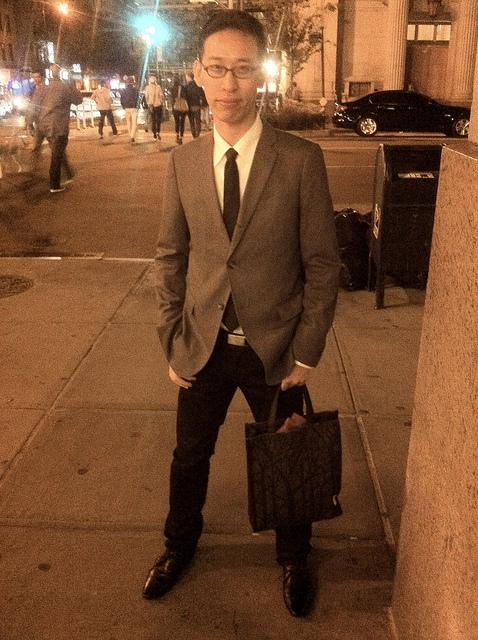What picture is on the bag?
Give a very brief answer. None. Is this man happy?
Answer briefly. No. Is this man wearing glasses?
Short answer required. Yes. What is the man holding in his hand?
Write a very short answer. Bag. What does the man have on his eyes?
Concise answer only. Glasses. 